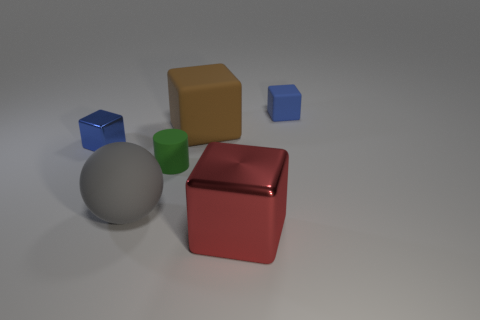What is the texture and sheen of the various objects in the image? The objects in the image exhibit varied textures and sheens. The large beige cube is matte and lacks any reflection, while the red cube has a high-gloss finish that reflects light, giving it a lustrous appearance. The smaller blue cube is also shiny but to a lesser extent. The metallic sphere is highly reflective, mirroring the environment, and the small green cylinder seems to be made of rubber with a matte, non-reflective surface. 